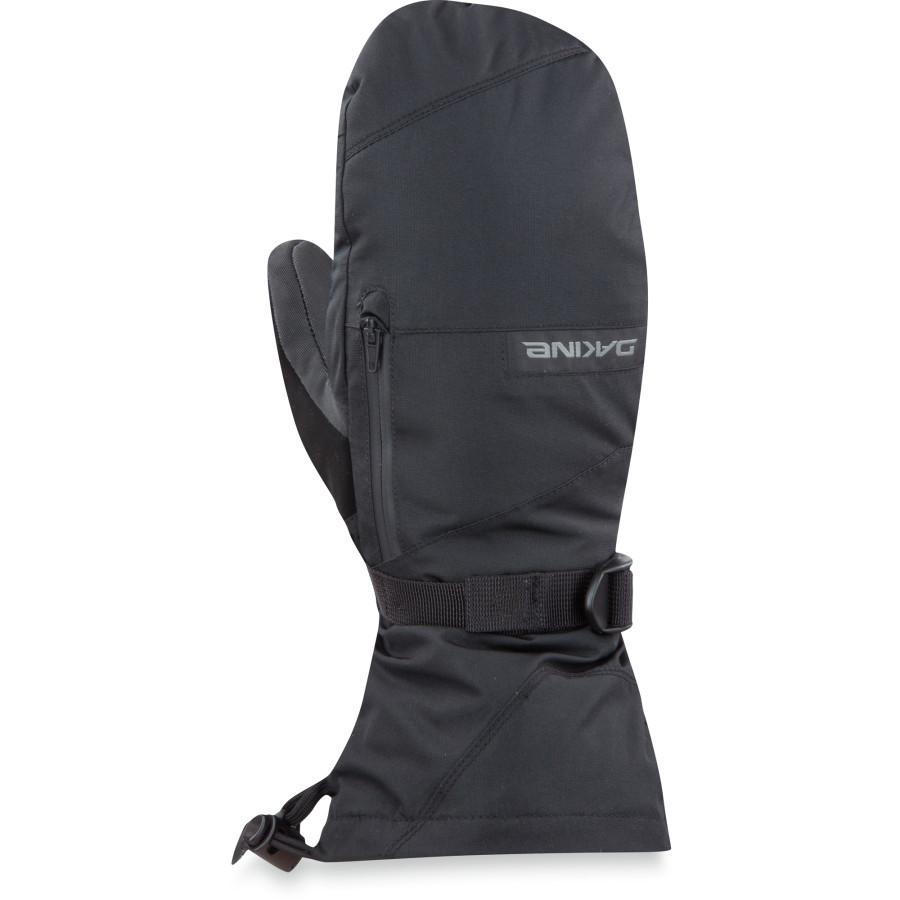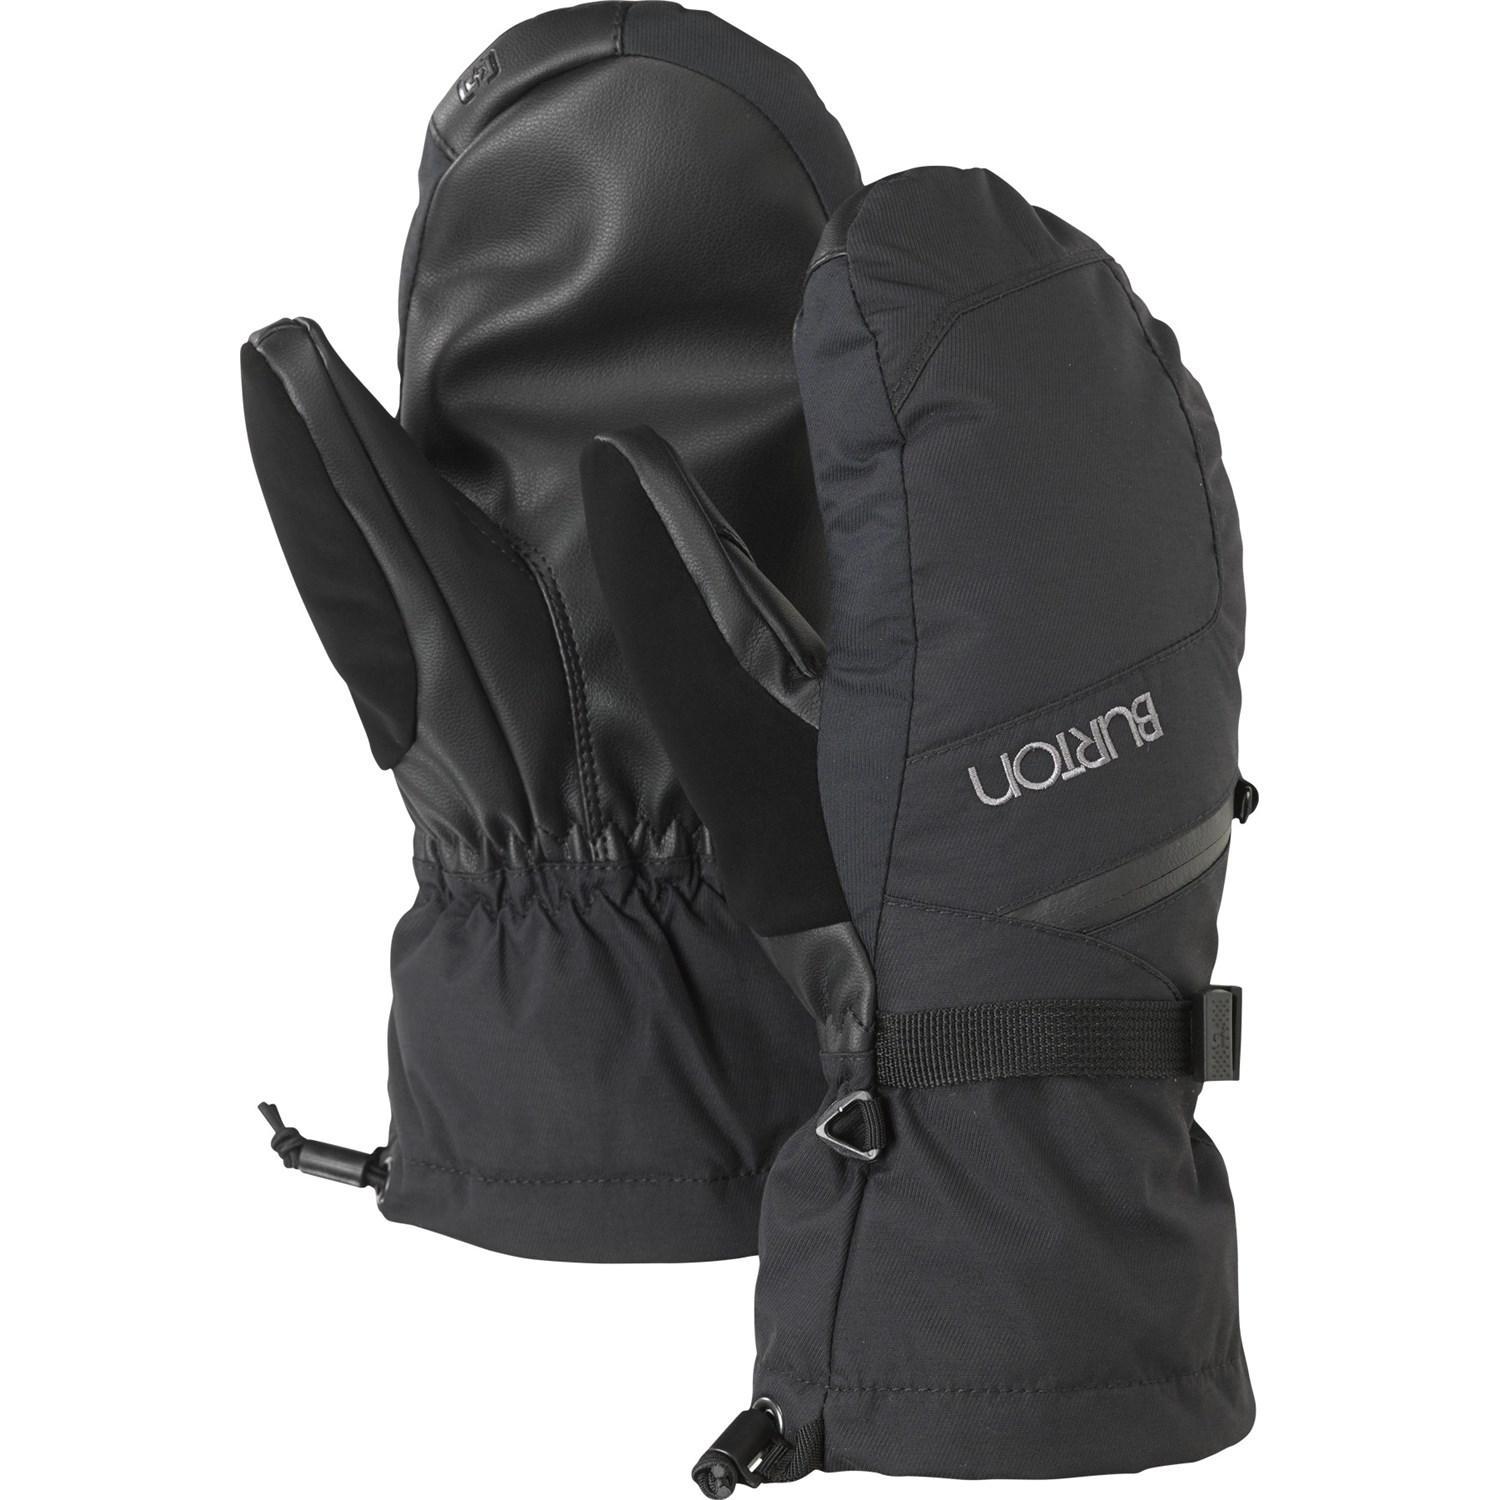The first image is the image on the left, the second image is the image on the right. Given the left and right images, does the statement "Mittens are decorated with fur/faux fur and contain colors other than black." hold true? Answer yes or no. No. The first image is the image on the left, the second image is the image on the right. Assess this claim about the two images: "One pair of gloves are knit.". Correct or not? Answer yes or no. No. 